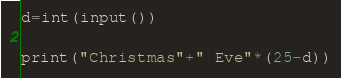Convert code to text. <code><loc_0><loc_0><loc_500><loc_500><_Python_>d=int(input())

print("Christmas"+" Eve"*(25-d))</code> 